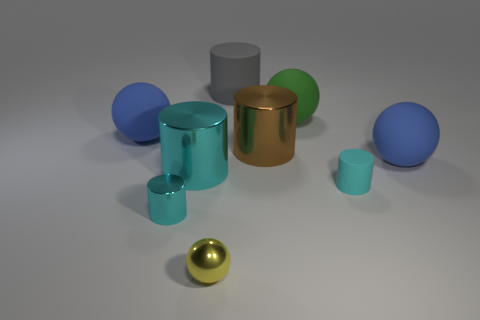The green rubber ball is what size?
Your answer should be compact. Large. How many big things are the same color as the tiny matte thing?
Keep it short and to the point. 1. There is a tiny cyan cylinder that is on the right side of the large green sphere that is on the right side of the tiny metal sphere; are there any cylinders that are in front of it?
Your response must be concise. Yes. The brown metal thing that is the same size as the green rubber thing is what shape?
Offer a terse response. Cylinder. How many tiny things are either brown metal objects or cyan matte cylinders?
Your response must be concise. 1. There is a big cylinder that is made of the same material as the big green object; what color is it?
Offer a very short reply. Gray. Is the shape of the small object that is to the right of the yellow object the same as the big metal object that is right of the yellow shiny ball?
Keep it short and to the point. Yes. How many metallic things are either small things or big green objects?
Your answer should be compact. 2. There is a large cylinder that is the same color as the tiny matte object; what is it made of?
Provide a succinct answer. Metal. What material is the green ball that is in front of the gray rubber thing?
Make the answer very short. Rubber. 